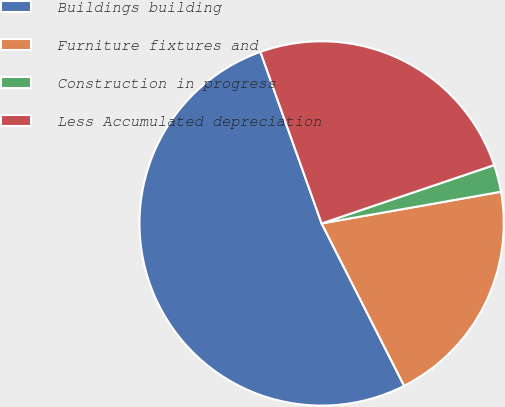<chart> <loc_0><loc_0><loc_500><loc_500><pie_chart><fcel>Buildings building<fcel>Furniture fixtures and<fcel>Construction in progress<fcel>Less Accumulated depreciation<nl><fcel>52.03%<fcel>20.3%<fcel>2.41%<fcel>25.26%<nl></chart> 